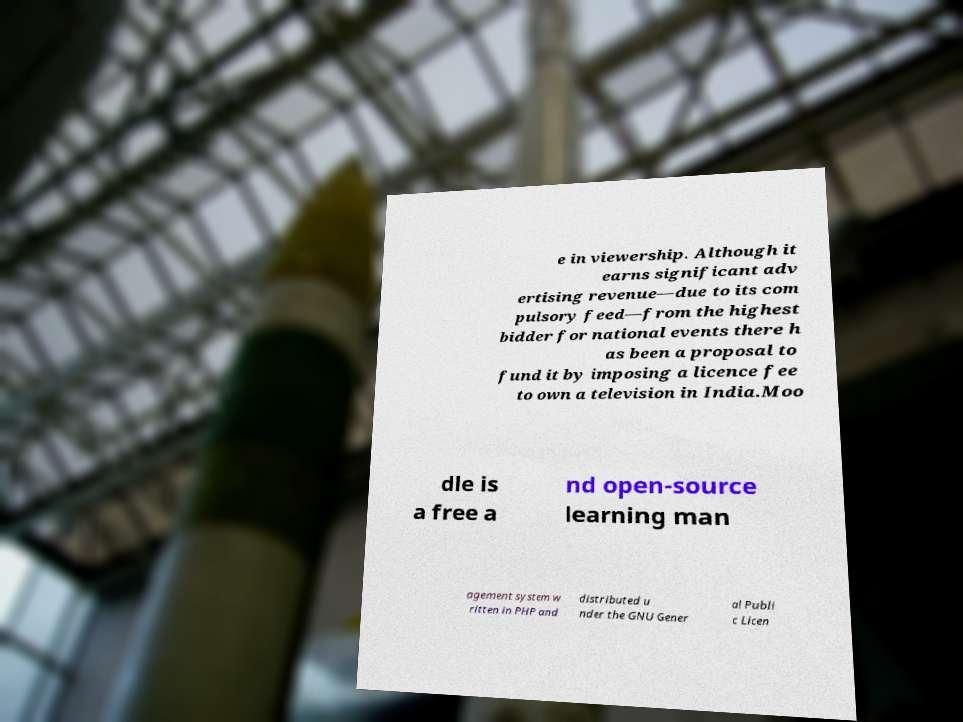I need the written content from this picture converted into text. Can you do that? e in viewership. Although it earns significant adv ertising revenue—due to its com pulsory feed—from the highest bidder for national events there h as been a proposal to fund it by imposing a licence fee to own a television in India.Moo dle is a free a nd open-source learning man agement system w ritten in PHP and distributed u nder the GNU Gener al Publi c Licen 